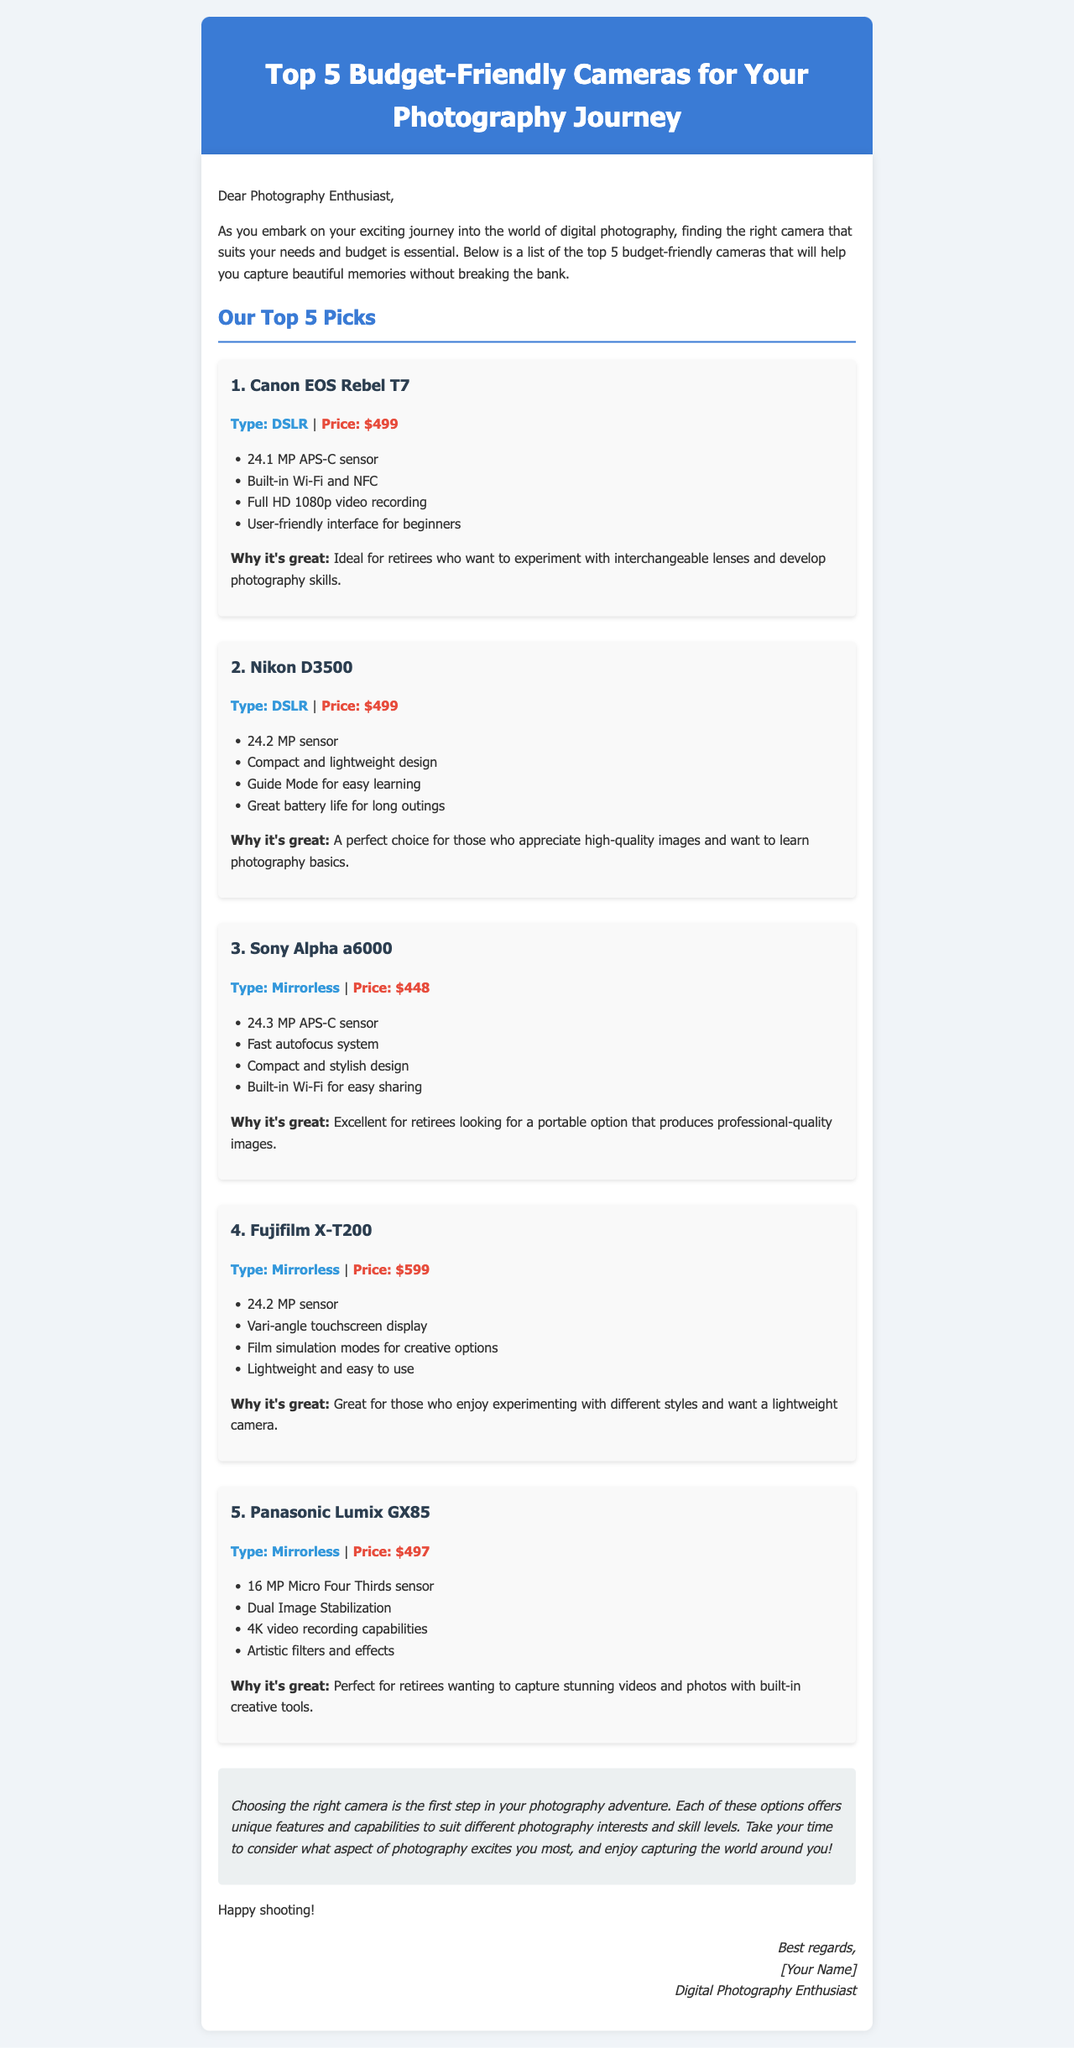What is the price of the Canon EOS Rebel T7? The price of the Canon EOS Rebel T7 is listed in the document as $499.
Answer: $499 How many megapixels does the Sony Alpha a6000 have? The document states that the Sony Alpha a6000 has a 24.3 MP APS-C sensor.
Answer: 24.3 MP Which camera is described as lightweight and easy to use? The Fujifilm X-T200 is highlighted in the document as lightweight and easy to use.
Answer: Fujifilm X-T200 What is the type of the Nikon D3500? The document specifies that the Nikon D3500 is a DSLR camera.
Answer: DSLR Which camera offers 4K video recording capabilities? The Panasonic Lumix GX85 is mentioned in the document as having 4K video recording capabilities.
Answer: Panasonic Lumix GX85 What feature does the Nikon D3500's Guide Mode provide? The Guide Mode in the Nikon D3500 is designed for easy learning, helping users understand photography basics.
Answer: Easy learning Which camera has a compact and stylish design? The Sony Alpha a6000 is characterized in the document as having a compact and stylish design.
Answer: Sony Alpha a6000 What concludes the email regarding choosing a camera? The conclusion of the email emphasizes taking time to consider what aspect of photography excites you most.
Answer: Enjoy capturing the world around you! What is the overall tone of the email? The tone of the email is friendly and encouraging, aimed at helping retirees explore photography.
Answer: Encouraging 